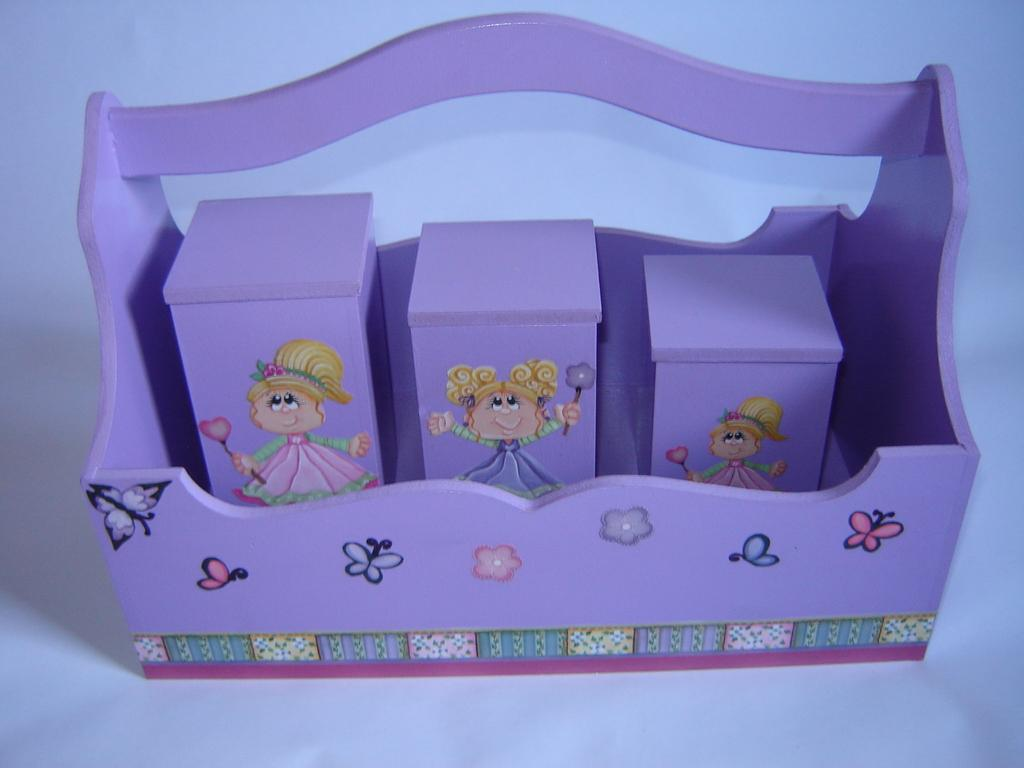What object is present in the image that can hold other items? There is a tray in the image. How many cubes are on the tray in the image? There are three cubes on the tray. What type of geese can be seen flying over the cubes in the image? There are no geese present in the image; it only features a tray with three cubes on it. What force is acting upon the cubes to keep them on the tray? The provided facts do not mention any force acting upon the cubes; they simply state that there are three cubes on the tray. What type of plastic material is the tray made of? The provided facts do not mention the material of the tray; it only states that there is a tray in the image. 